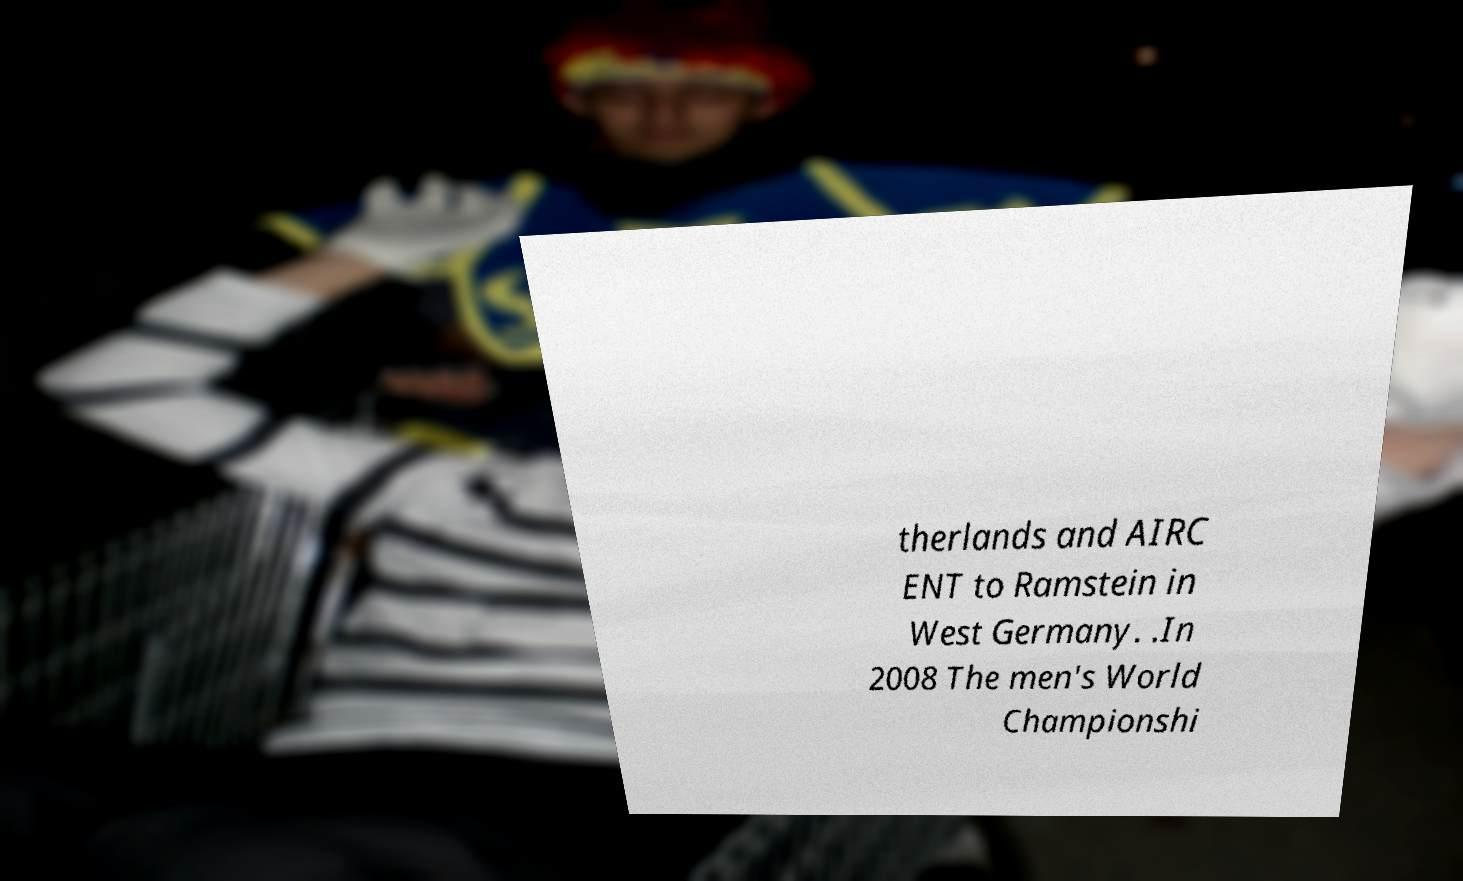Could you assist in decoding the text presented in this image and type it out clearly? therlands and AIRC ENT to Ramstein in West Germany. .In 2008 The men's World Championshi 